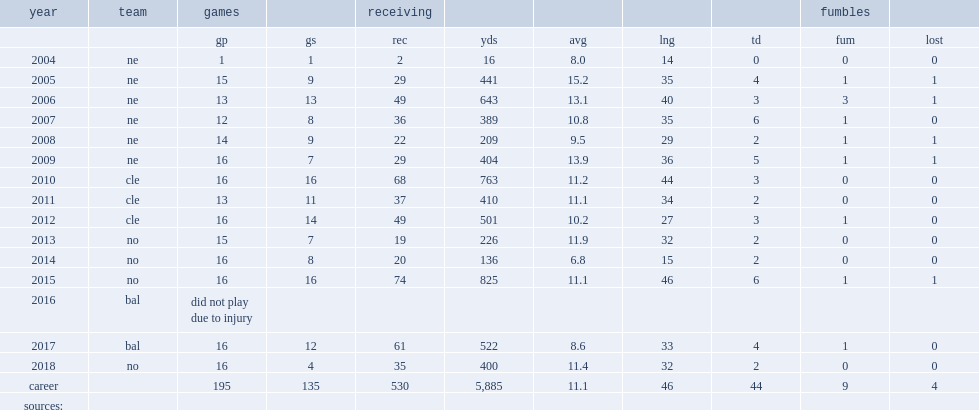What was the number of receiving yards that watson got in 2007? 389.0. 